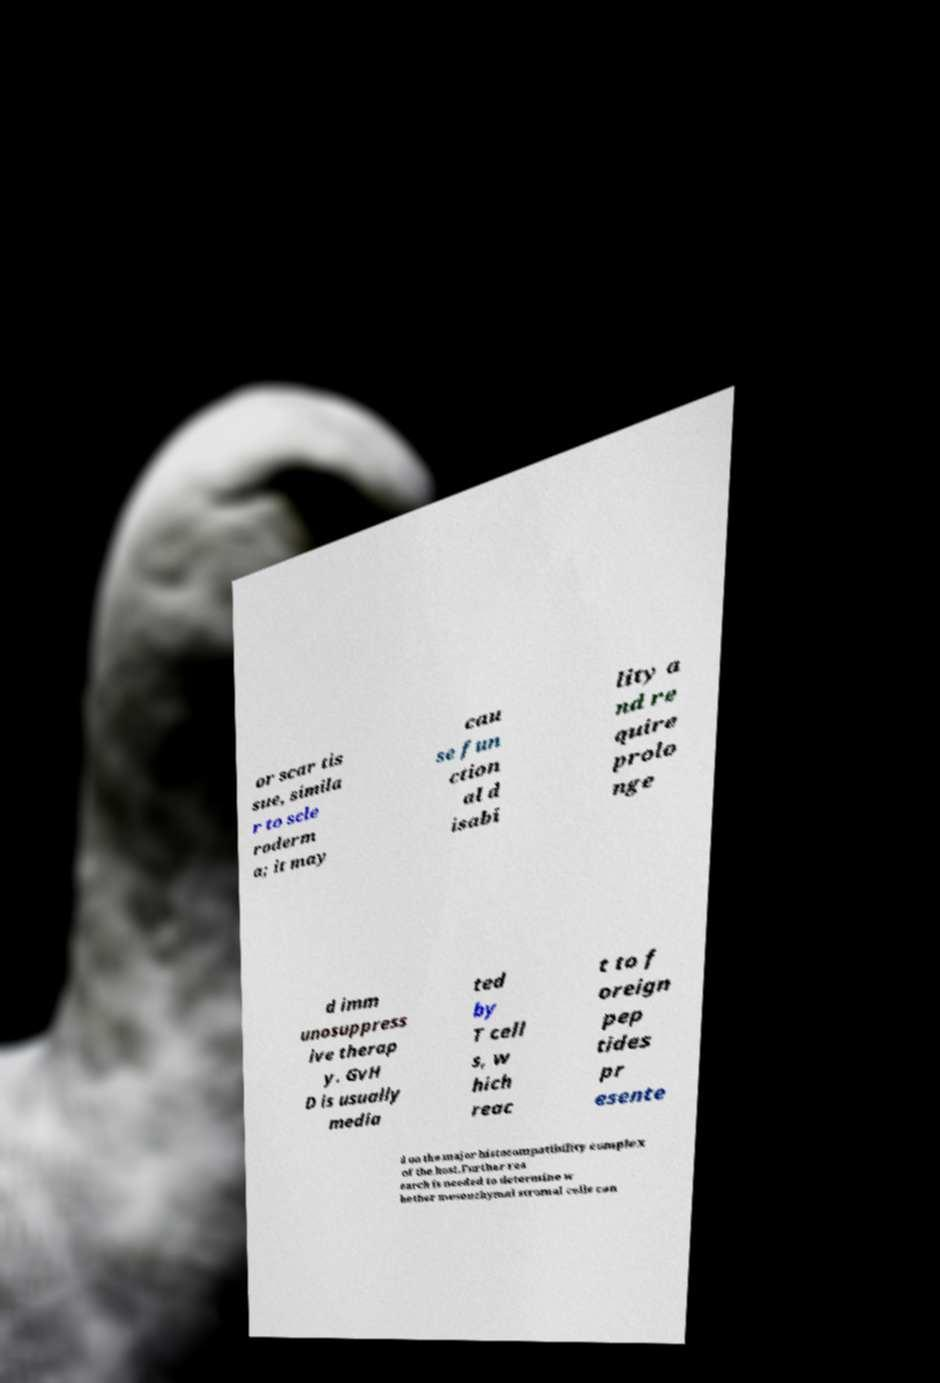Can you accurately transcribe the text from the provided image for me? or scar tis sue, simila r to scle roderm a; it may cau se fun ction al d isabi lity a nd re quire prolo nge d imm unosuppress ive therap y. GvH D is usually media ted by T cell s, w hich reac t to f oreign pep tides pr esente d on the major histocompatibility complex of the host.Further res earch is needed to determine w hether mesenchymal stromal cells can 